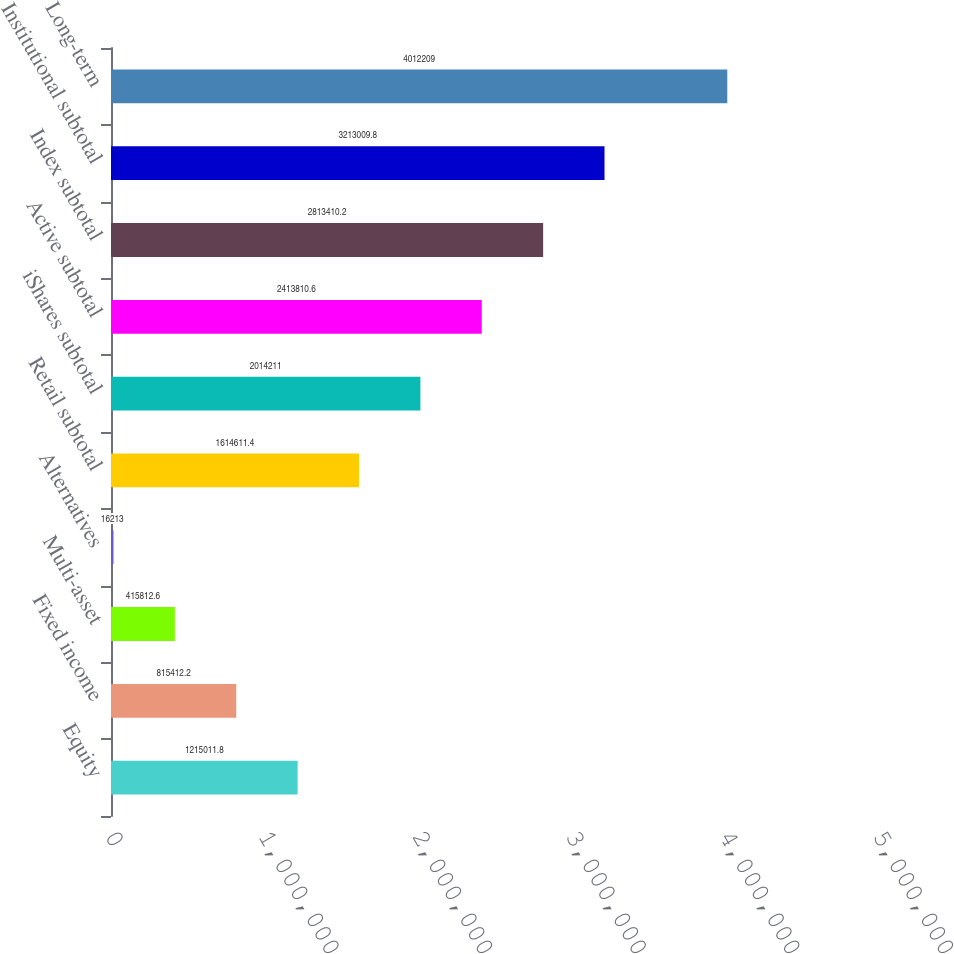Convert chart to OTSL. <chart><loc_0><loc_0><loc_500><loc_500><bar_chart><fcel>Equity<fcel>Fixed income<fcel>Multi-asset<fcel>Alternatives<fcel>Retail subtotal<fcel>iShares subtotal<fcel>Active subtotal<fcel>Index subtotal<fcel>Institutional subtotal<fcel>Long-term<nl><fcel>1.21501e+06<fcel>815412<fcel>415813<fcel>16213<fcel>1.61461e+06<fcel>2.01421e+06<fcel>2.41381e+06<fcel>2.81341e+06<fcel>3.21301e+06<fcel>4.01221e+06<nl></chart> 